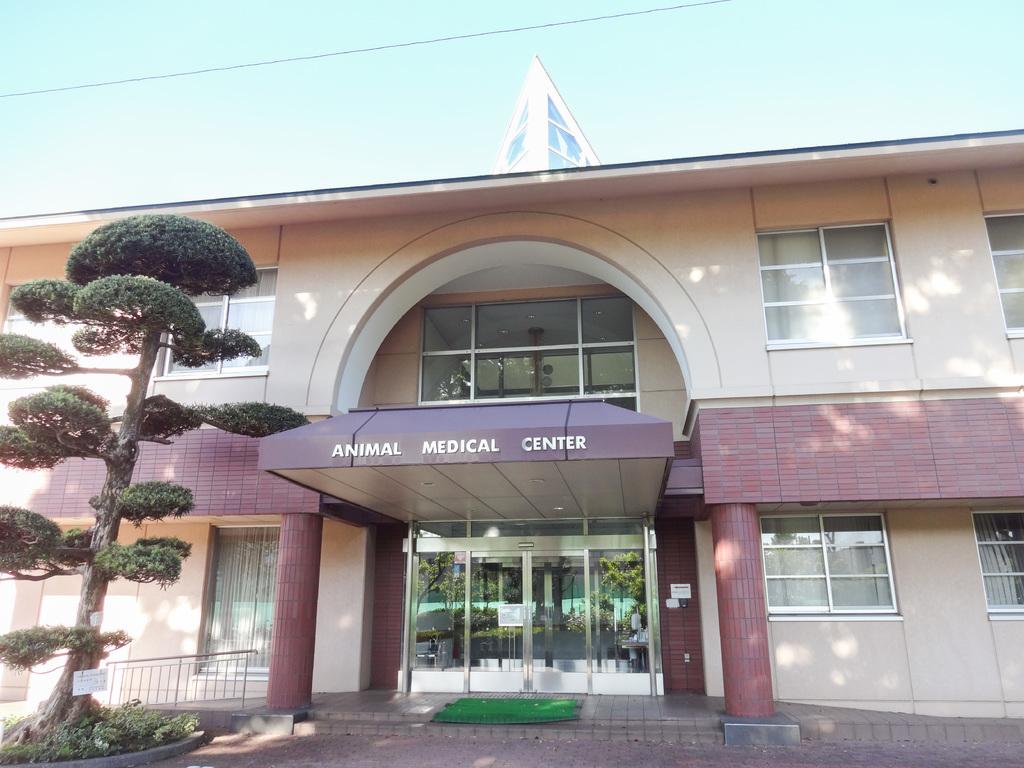What kind of business is this?
Offer a very short reply. Animal medical center. What is that a medical center for?
Offer a very short reply. Animals. 